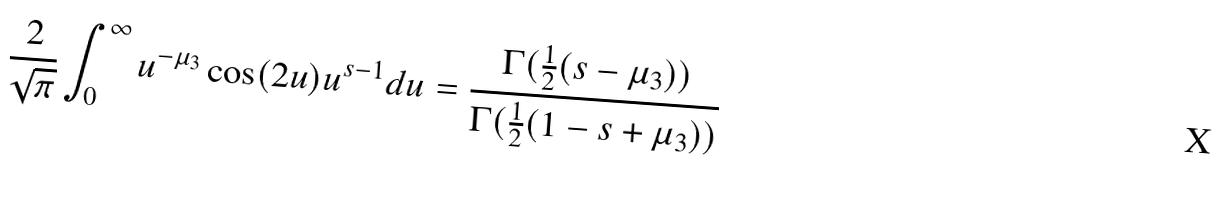Convert formula to latex. <formula><loc_0><loc_0><loc_500><loc_500>\frac { 2 } { \sqrt { \pi } } \int _ { 0 } ^ { \infty } u ^ { - \mu _ { 3 } } \cos ( 2 u ) u ^ { s - 1 } d u = \frac { \Gamma ( \frac { 1 } { 2 } ( s - \mu _ { 3 } ) ) } { \Gamma ( \frac { 1 } { 2 } ( 1 - s + \mu _ { 3 } ) ) }</formula> 